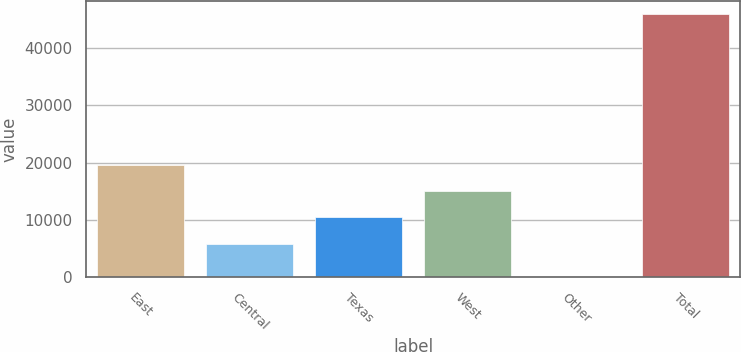Convert chart. <chart><loc_0><loc_0><loc_500><loc_500><bar_chart><fcel>East<fcel>Central<fcel>Texas<fcel>West<fcel>Other<fcel>Total<nl><fcel>19578.8<fcel>5855<fcel>10429.6<fcel>15004.2<fcel>80<fcel>45826<nl></chart> 